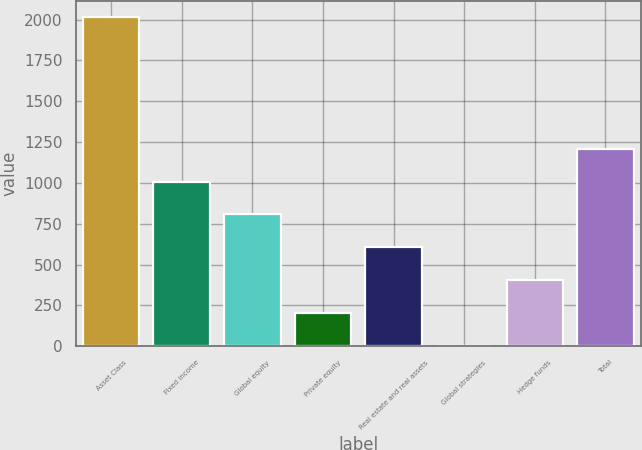Convert chart to OTSL. <chart><loc_0><loc_0><loc_500><loc_500><bar_chart><fcel>Asset Class<fcel>Fixed income<fcel>Global equity<fcel>Private equity<fcel>Real estate and real assets<fcel>Global strategies<fcel>Hedge funds<fcel>Total<nl><fcel>2013<fcel>1008.5<fcel>807.6<fcel>204.9<fcel>606.7<fcel>4<fcel>405.8<fcel>1209.4<nl></chart> 